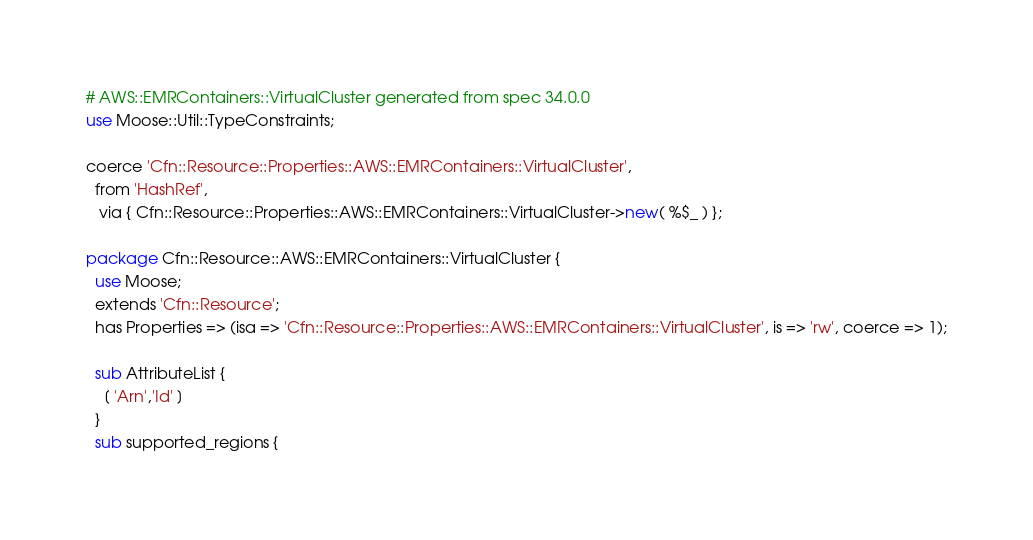<code> <loc_0><loc_0><loc_500><loc_500><_Perl_># AWS::EMRContainers::VirtualCluster generated from spec 34.0.0
use Moose::Util::TypeConstraints;

coerce 'Cfn::Resource::Properties::AWS::EMRContainers::VirtualCluster',
  from 'HashRef',
   via { Cfn::Resource::Properties::AWS::EMRContainers::VirtualCluster->new( %$_ ) };

package Cfn::Resource::AWS::EMRContainers::VirtualCluster {
  use Moose;
  extends 'Cfn::Resource';
  has Properties => (isa => 'Cfn::Resource::Properties::AWS::EMRContainers::VirtualCluster', is => 'rw', coerce => 1);
  
  sub AttributeList {
    [ 'Arn','Id' ]
  }
  sub supported_regions {</code> 